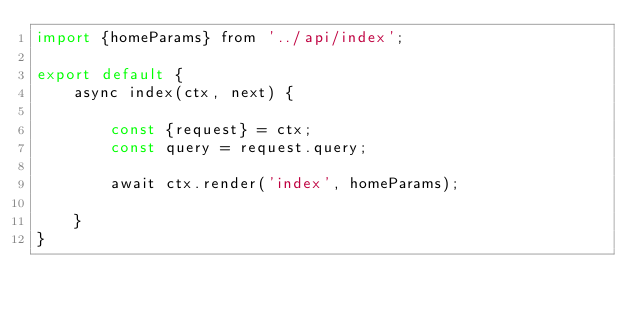Convert code to text. <code><loc_0><loc_0><loc_500><loc_500><_JavaScript_>import {homeParams} from '../api/index';

export default {
    async index(ctx, next) {

        const {request} = ctx;
        const query = request.query;

        await ctx.render('index', homeParams);

    }
}
</code> 